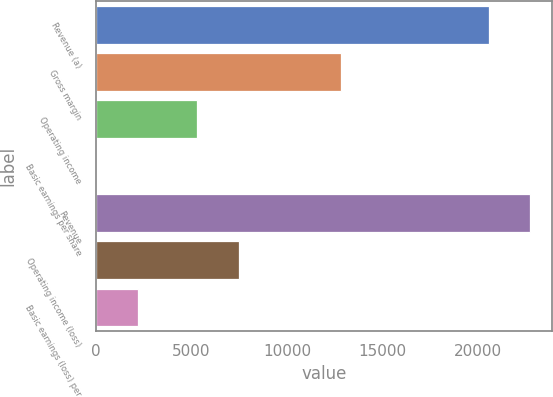<chart> <loc_0><loc_0><loc_500><loc_500><bar_chart><fcel>Revenue (a)<fcel>Gross margin<fcel>Operating income<fcel>Basic earnings per share<fcel>Revenue<fcel>Operating income (loss)<fcel>Basic earnings (loss) per<nl><fcel>20531<fcel>12809<fcel>5283<fcel>0.48<fcel>22703.8<fcel>7455.85<fcel>2173.33<nl></chart> 